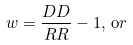Convert formula to latex. <formula><loc_0><loc_0><loc_500><loc_500>w = \frac { D D } { R R } - 1 , \, { \mathrm o r }</formula> 